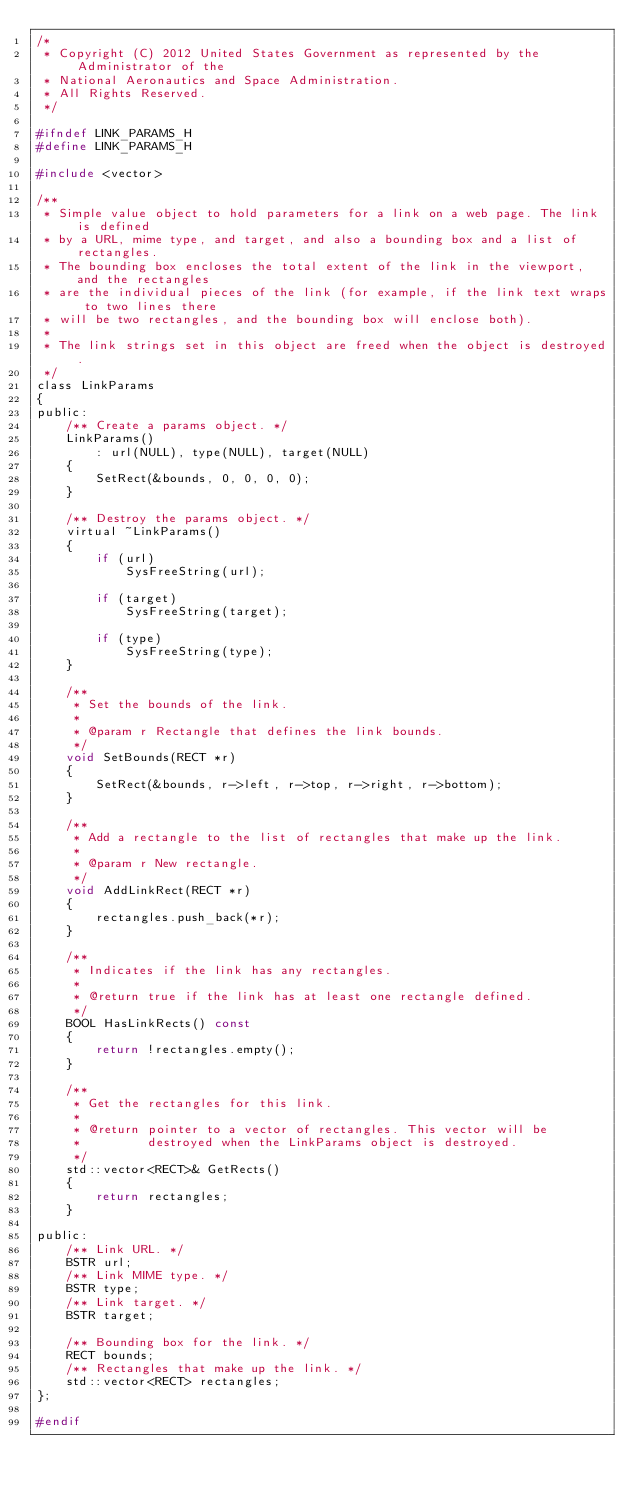<code> <loc_0><loc_0><loc_500><loc_500><_C_>/*
 * Copyright (C) 2012 United States Government as represented by the Administrator of the
 * National Aeronautics and Space Administration.
 * All Rights Reserved.
 */

#ifndef LINK_PARAMS_H
#define LINK_PARAMS_H

#include <vector>

/**
 * Simple value object to hold parameters for a link on a web page. The link is defined
 * by a URL, mime type, and target, and also a bounding box and a list of rectangles.
 * The bounding box encloses the total extent of the link in the viewport, and the rectangles
 * are the individual pieces of the link (for example, if the link text wraps to two lines there
 * will be two rectangles, and the bounding box will enclose both).
 * 
 * The link strings set in this object are freed when the object is destroyed.
 */
class LinkParams
{
public:
    /** Create a params object. */
    LinkParams()
        : url(NULL), type(NULL), target(NULL)
    {
        SetRect(&bounds, 0, 0, 0, 0);
    }

    /** Destroy the params object. */
    virtual ~LinkParams()
    {
        if (url)
            SysFreeString(url);

        if (target)
            SysFreeString(target);

        if (type)
            SysFreeString(type);
    }

    /**
     * Set the bounds of the link.
     *
     * @param r Rectangle that defines the link bounds.
     */
    void SetBounds(RECT *r)
    {
        SetRect(&bounds, r->left, r->top, r->right, r->bottom);
    }

    /**
     * Add a rectangle to the list of rectangles that make up the link.
     *
     * @param r New rectangle.
     */
    void AddLinkRect(RECT *r)
    {
        rectangles.push_back(*r);
    }

    /**
     * Indicates if the link has any rectangles.
     *
     * @return true if the link has at least one rectangle defined.
     */
    BOOL HasLinkRects() const
    {
        return !rectangles.empty();
    }

    /**
     * Get the rectangles for this link.
     *
     * @return pointer to a vector of rectangles. This vector will be
     *         destroyed when the LinkParams object is destroyed.
     */
    std::vector<RECT>& GetRects()
    {
        return rectangles;
    }

public:
    /** Link URL. */
    BSTR url;
    /** Link MIME type. */     
    BSTR type;
    /** Link target. */
    BSTR target;

    /** Bounding box for the link. */
    RECT bounds;
    /** Rectangles that make up the link. */
    std::vector<RECT> rectangles;
};

#endif</code> 